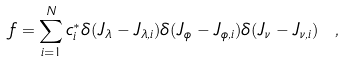<formula> <loc_0><loc_0><loc_500><loc_500>f = \sum _ { i = 1 } ^ { N } c _ { i } ^ { \ast } \delta ( J _ { \lambda } - J _ { \lambda , i } ) \delta ( J _ { \phi } - J _ { \phi , i } ) \delta ( J _ { \nu } - J _ { \nu , i } ) \ ,</formula> 